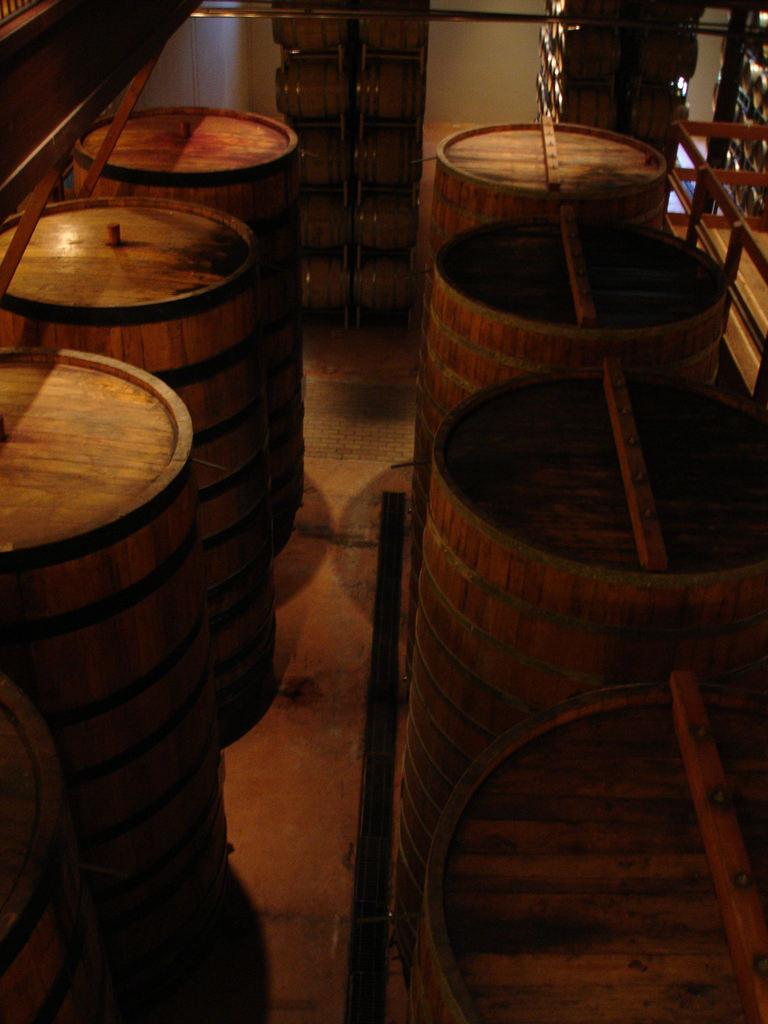What type of room is depicted in the image? The image shows the inner view of a room. What musical instrument can be seen in the room? There are drums on a surface in the room. What color is the wall in the room? There is a white wall in the room. What other objects are present on the surface with the drums? There are various objects on the surface in the room. What type of joke can be seen written on the wall in the image? There is no joke written on the wall in the image; it is a white wall with no visible text or images. 